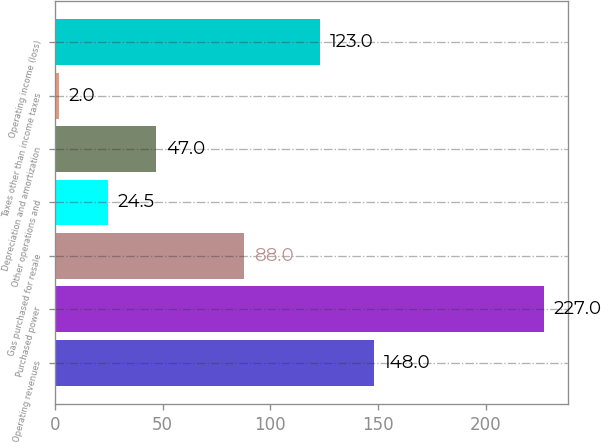Convert chart to OTSL. <chart><loc_0><loc_0><loc_500><loc_500><bar_chart><fcel>Operating revenues<fcel>Purchased power<fcel>Gas purchased for resale<fcel>Other operations and<fcel>Depreciation and amortization<fcel>Taxes other than income taxes<fcel>Operating income (loss)<nl><fcel>148<fcel>227<fcel>88<fcel>24.5<fcel>47<fcel>2<fcel>123<nl></chart> 